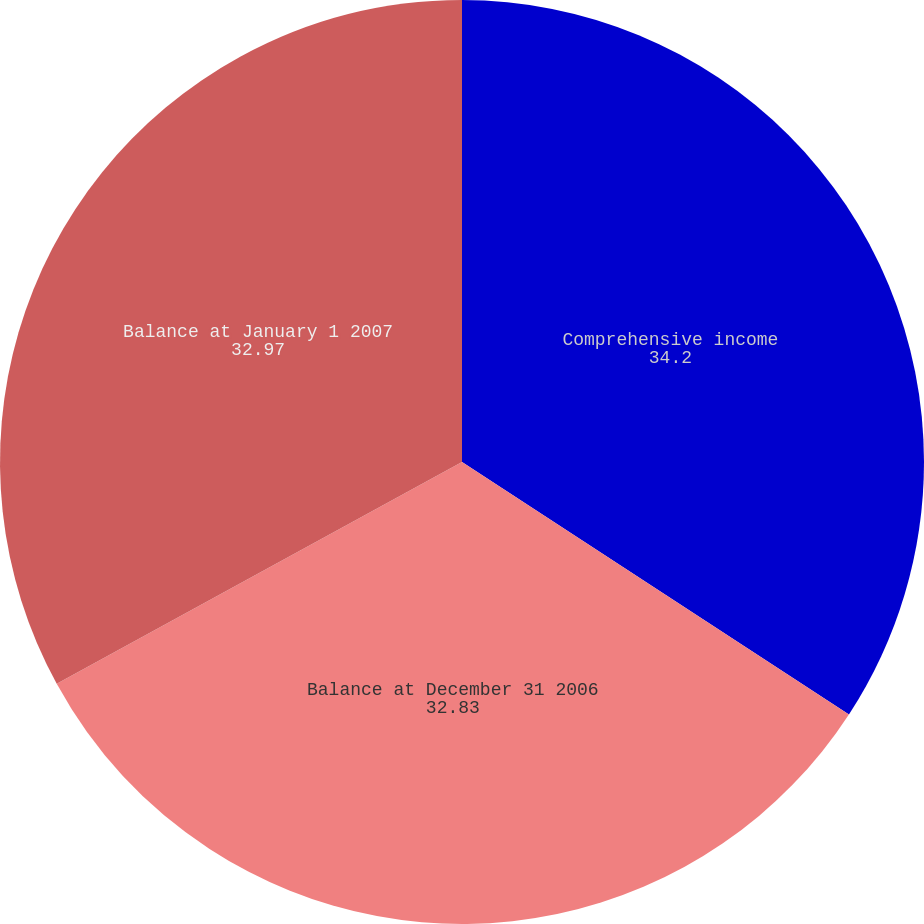Convert chart. <chart><loc_0><loc_0><loc_500><loc_500><pie_chart><fcel>Comprehensive income<fcel>Balance at December 31 2006<fcel>Balance at January 1 2007<nl><fcel>34.2%<fcel>32.83%<fcel>32.97%<nl></chart> 